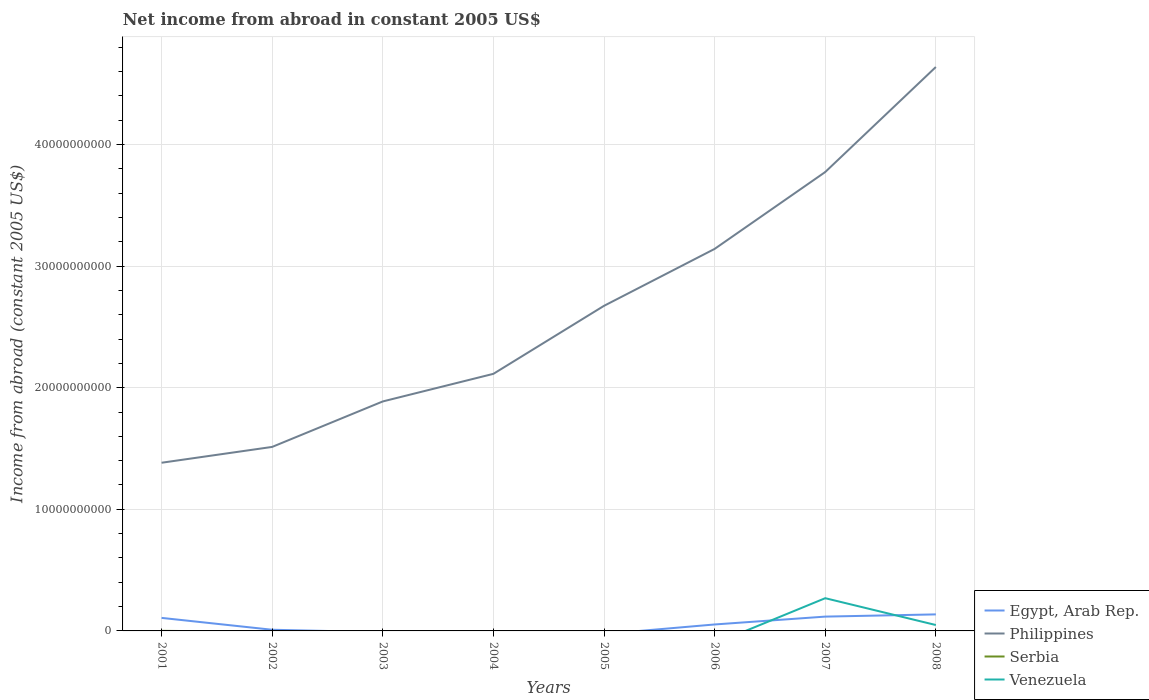How many different coloured lines are there?
Make the answer very short. 4. What is the total net income from abroad in Philippines in the graph?
Give a very brief answer. -1.30e+09. What is the difference between the highest and the second highest net income from abroad in Serbia?
Ensure brevity in your answer.  6.03e+06. How many lines are there?
Your answer should be very brief. 4. How many years are there in the graph?
Keep it short and to the point. 8. Are the values on the major ticks of Y-axis written in scientific E-notation?
Offer a very short reply. No. Does the graph contain any zero values?
Provide a succinct answer. Yes. Does the graph contain grids?
Keep it short and to the point. Yes. How are the legend labels stacked?
Offer a terse response. Vertical. What is the title of the graph?
Provide a succinct answer. Net income from abroad in constant 2005 US$. What is the label or title of the Y-axis?
Ensure brevity in your answer.  Income from abroad (constant 2005 US$). What is the Income from abroad (constant 2005 US$) of Egypt, Arab Rep. in 2001?
Give a very brief answer. 1.07e+09. What is the Income from abroad (constant 2005 US$) of Philippines in 2001?
Provide a short and direct response. 1.38e+1. What is the Income from abroad (constant 2005 US$) in Serbia in 2001?
Your answer should be very brief. 6.03e+06. What is the Income from abroad (constant 2005 US$) in Egypt, Arab Rep. in 2002?
Your answer should be very brief. 9.59e+07. What is the Income from abroad (constant 2005 US$) in Philippines in 2002?
Make the answer very short. 1.51e+1. What is the Income from abroad (constant 2005 US$) in Serbia in 2002?
Make the answer very short. 0. What is the Income from abroad (constant 2005 US$) of Philippines in 2003?
Offer a very short reply. 1.89e+1. What is the Income from abroad (constant 2005 US$) of Serbia in 2003?
Your answer should be compact. 0. What is the Income from abroad (constant 2005 US$) in Venezuela in 2003?
Provide a succinct answer. 0. What is the Income from abroad (constant 2005 US$) of Philippines in 2004?
Ensure brevity in your answer.  2.11e+1. What is the Income from abroad (constant 2005 US$) in Egypt, Arab Rep. in 2005?
Make the answer very short. 0. What is the Income from abroad (constant 2005 US$) in Philippines in 2005?
Offer a terse response. 2.67e+1. What is the Income from abroad (constant 2005 US$) in Serbia in 2005?
Ensure brevity in your answer.  0. What is the Income from abroad (constant 2005 US$) in Egypt, Arab Rep. in 2006?
Keep it short and to the point. 5.31e+08. What is the Income from abroad (constant 2005 US$) in Philippines in 2006?
Keep it short and to the point. 3.14e+1. What is the Income from abroad (constant 2005 US$) in Serbia in 2006?
Provide a short and direct response. 0. What is the Income from abroad (constant 2005 US$) of Venezuela in 2006?
Your response must be concise. 0. What is the Income from abroad (constant 2005 US$) in Egypt, Arab Rep. in 2007?
Ensure brevity in your answer.  1.18e+09. What is the Income from abroad (constant 2005 US$) of Philippines in 2007?
Make the answer very short. 3.77e+1. What is the Income from abroad (constant 2005 US$) of Serbia in 2007?
Offer a terse response. 0. What is the Income from abroad (constant 2005 US$) in Venezuela in 2007?
Provide a short and direct response. 2.69e+09. What is the Income from abroad (constant 2005 US$) of Egypt, Arab Rep. in 2008?
Provide a succinct answer. 1.36e+09. What is the Income from abroad (constant 2005 US$) in Philippines in 2008?
Make the answer very short. 4.64e+1. What is the Income from abroad (constant 2005 US$) in Venezuela in 2008?
Keep it short and to the point. 4.85e+08. Across all years, what is the maximum Income from abroad (constant 2005 US$) in Egypt, Arab Rep.?
Provide a short and direct response. 1.36e+09. Across all years, what is the maximum Income from abroad (constant 2005 US$) in Philippines?
Offer a terse response. 4.64e+1. Across all years, what is the maximum Income from abroad (constant 2005 US$) in Serbia?
Offer a terse response. 6.03e+06. Across all years, what is the maximum Income from abroad (constant 2005 US$) in Venezuela?
Your answer should be compact. 2.69e+09. Across all years, what is the minimum Income from abroad (constant 2005 US$) of Philippines?
Offer a very short reply. 1.38e+1. What is the total Income from abroad (constant 2005 US$) of Egypt, Arab Rep. in the graph?
Give a very brief answer. 4.24e+09. What is the total Income from abroad (constant 2005 US$) in Philippines in the graph?
Your answer should be very brief. 2.11e+11. What is the total Income from abroad (constant 2005 US$) in Serbia in the graph?
Provide a succinct answer. 6.03e+06. What is the total Income from abroad (constant 2005 US$) of Venezuela in the graph?
Keep it short and to the point. 3.18e+09. What is the difference between the Income from abroad (constant 2005 US$) in Egypt, Arab Rep. in 2001 and that in 2002?
Provide a succinct answer. 9.76e+08. What is the difference between the Income from abroad (constant 2005 US$) in Philippines in 2001 and that in 2002?
Make the answer very short. -1.30e+09. What is the difference between the Income from abroad (constant 2005 US$) of Philippines in 2001 and that in 2003?
Offer a very short reply. -5.04e+09. What is the difference between the Income from abroad (constant 2005 US$) in Philippines in 2001 and that in 2004?
Keep it short and to the point. -7.31e+09. What is the difference between the Income from abroad (constant 2005 US$) of Philippines in 2001 and that in 2005?
Make the answer very short. -1.29e+1. What is the difference between the Income from abroad (constant 2005 US$) of Egypt, Arab Rep. in 2001 and that in 2006?
Your answer should be very brief. 5.41e+08. What is the difference between the Income from abroad (constant 2005 US$) of Philippines in 2001 and that in 2006?
Keep it short and to the point. -1.76e+1. What is the difference between the Income from abroad (constant 2005 US$) in Egypt, Arab Rep. in 2001 and that in 2007?
Provide a short and direct response. -1.06e+08. What is the difference between the Income from abroad (constant 2005 US$) in Philippines in 2001 and that in 2007?
Offer a very short reply. -2.39e+1. What is the difference between the Income from abroad (constant 2005 US$) of Egypt, Arab Rep. in 2001 and that in 2008?
Keep it short and to the point. -2.88e+08. What is the difference between the Income from abroad (constant 2005 US$) of Philippines in 2001 and that in 2008?
Your answer should be very brief. -3.25e+1. What is the difference between the Income from abroad (constant 2005 US$) in Philippines in 2002 and that in 2003?
Give a very brief answer. -3.74e+09. What is the difference between the Income from abroad (constant 2005 US$) in Philippines in 2002 and that in 2004?
Provide a short and direct response. -6.01e+09. What is the difference between the Income from abroad (constant 2005 US$) in Philippines in 2002 and that in 2005?
Your response must be concise. -1.16e+1. What is the difference between the Income from abroad (constant 2005 US$) in Egypt, Arab Rep. in 2002 and that in 2006?
Provide a succinct answer. -4.35e+08. What is the difference between the Income from abroad (constant 2005 US$) of Philippines in 2002 and that in 2006?
Give a very brief answer. -1.63e+1. What is the difference between the Income from abroad (constant 2005 US$) of Egypt, Arab Rep. in 2002 and that in 2007?
Give a very brief answer. -1.08e+09. What is the difference between the Income from abroad (constant 2005 US$) in Philippines in 2002 and that in 2007?
Ensure brevity in your answer.  -2.26e+1. What is the difference between the Income from abroad (constant 2005 US$) in Egypt, Arab Rep. in 2002 and that in 2008?
Offer a terse response. -1.26e+09. What is the difference between the Income from abroad (constant 2005 US$) of Philippines in 2002 and that in 2008?
Offer a very short reply. -3.12e+1. What is the difference between the Income from abroad (constant 2005 US$) in Philippines in 2003 and that in 2004?
Offer a terse response. -2.27e+09. What is the difference between the Income from abroad (constant 2005 US$) in Philippines in 2003 and that in 2005?
Provide a succinct answer. -7.86e+09. What is the difference between the Income from abroad (constant 2005 US$) in Philippines in 2003 and that in 2006?
Provide a succinct answer. -1.25e+1. What is the difference between the Income from abroad (constant 2005 US$) in Philippines in 2003 and that in 2007?
Your answer should be very brief. -1.89e+1. What is the difference between the Income from abroad (constant 2005 US$) in Philippines in 2003 and that in 2008?
Provide a succinct answer. -2.75e+1. What is the difference between the Income from abroad (constant 2005 US$) in Philippines in 2004 and that in 2005?
Your answer should be compact. -5.59e+09. What is the difference between the Income from abroad (constant 2005 US$) in Philippines in 2004 and that in 2006?
Offer a very short reply. -1.03e+1. What is the difference between the Income from abroad (constant 2005 US$) in Philippines in 2004 and that in 2007?
Offer a terse response. -1.66e+1. What is the difference between the Income from abroad (constant 2005 US$) of Philippines in 2004 and that in 2008?
Your answer should be very brief. -2.52e+1. What is the difference between the Income from abroad (constant 2005 US$) in Philippines in 2005 and that in 2006?
Keep it short and to the point. -4.68e+09. What is the difference between the Income from abroad (constant 2005 US$) in Philippines in 2005 and that in 2007?
Offer a very short reply. -1.10e+1. What is the difference between the Income from abroad (constant 2005 US$) in Philippines in 2005 and that in 2008?
Provide a succinct answer. -1.96e+1. What is the difference between the Income from abroad (constant 2005 US$) of Egypt, Arab Rep. in 2006 and that in 2007?
Keep it short and to the point. -6.46e+08. What is the difference between the Income from abroad (constant 2005 US$) of Philippines in 2006 and that in 2007?
Provide a succinct answer. -6.32e+09. What is the difference between the Income from abroad (constant 2005 US$) of Egypt, Arab Rep. in 2006 and that in 2008?
Provide a succinct answer. -8.29e+08. What is the difference between the Income from abroad (constant 2005 US$) in Philippines in 2006 and that in 2008?
Provide a succinct answer. -1.50e+1. What is the difference between the Income from abroad (constant 2005 US$) in Egypt, Arab Rep. in 2007 and that in 2008?
Offer a terse response. -1.82e+08. What is the difference between the Income from abroad (constant 2005 US$) in Philippines in 2007 and that in 2008?
Provide a short and direct response. -8.64e+09. What is the difference between the Income from abroad (constant 2005 US$) in Venezuela in 2007 and that in 2008?
Ensure brevity in your answer.  2.21e+09. What is the difference between the Income from abroad (constant 2005 US$) of Egypt, Arab Rep. in 2001 and the Income from abroad (constant 2005 US$) of Philippines in 2002?
Your response must be concise. -1.41e+1. What is the difference between the Income from abroad (constant 2005 US$) of Egypt, Arab Rep. in 2001 and the Income from abroad (constant 2005 US$) of Philippines in 2003?
Keep it short and to the point. -1.78e+1. What is the difference between the Income from abroad (constant 2005 US$) of Egypt, Arab Rep. in 2001 and the Income from abroad (constant 2005 US$) of Philippines in 2004?
Offer a very short reply. -2.01e+1. What is the difference between the Income from abroad (constant 2005 US$) of Egypt, Arab Rep. in 2001 and the Income from abroad (constant 2005 US$) of Philippines in 2005?
Your answer should be very brief. -2.57e+1. What is the difference between the Income from abroad (constant 2005 US$) of Egypt, Arab Rep. in 2001 and the Income from abroad (constant 2005 US$) of Philippines in 2006?
Offer a very short reply. -3.03e+1. What is the difference between the Income from abroad (constant 2005 US$) of Egypt, Arab Rep. in 2001 and the Income from abroad (constant 2005 US$) of Philippines in 2007?
Your answer should be very brief. -3.67e+1. What is the difference between the Income from abroad (constant 2005 US$) in Egypt, Arab Rep. in 2001 and the Income from abroad (constant 2005 US$) in Venezuela in 2007?
Your response must be concise. -1.62e+09. What is the difference between the Income from abroad (constant 2005 US$) of Philippines in 2001 and the Income from abroad (constant 2005 US$) of Venezuela in 2007?
Make the answer very short. 1.11e+1. What is the difference between the Income from abroad (constant 2005 US$) in Serbia in 2001 and the Income from abroad (constant 2005 US$) in Venezuela in 2007?
Ensure brevity in your answer.  -2.69e+09. What is the difference between the Income from abroad (constant 2005 US$) of Egypt, Arab Rep. in 2001 and the Income from abroad (constant 2005 US$) of Philippines in 2008?
Provide a succinct answer. -4.53e+1. What is the difference between the Income from abroad (constant 2005 US$) in Egypt, Arab Rep. in 2001 and the Income from abroad (constant 2005 US$) in Venezuela in 2008?
Offer a very short reply. 5.87e+08. What is the difference between the Income from abroad (constant 2005 US$) of Philippines in 2001 and the Income from abroad (constant 2005 US$) of Venezuela in 2008?
Provide a short and direct response. 1.33e+1. What is the difference between the Income from abroad (constant 2005 US$) of Serbia in 2001 and the Income from abroad (constant 2005 US$) of Venezuela in 2008?
Your response must be concise. -4.79e+08. What is the difference between the Income from abroad (constant 2005 US$) in Egypt, Arab Rep. in 2002 and the Income from abroad (constant 2005 US$) in Philippines in 2003?
Provide a short and direct response. -1.88e+1. What is the difference between the Income from abroad (constant 2005 US$) in Egypt, Arab Rep. in 2002 and the Income from abroad (constant 2005 US$) in Philippines in 2004?
Provide a short and direct response. -2.10e+1. What is the difference between the Income from abroad (constant 2005 US$) of Egypt, Arab Rep. in 2002 and the Income from abroad (constant 2005 US$) of Philippines in 2005?
Give a very brief answer. -2.66e+1. What is the difference between the Income from abroad (constant 2005 US$) of Egypt, Arab Rep. in 2002 and the Income from abroad (constant 2005 US$) of Philippines in 2006?
Ensure brevity in your answer.  -3.13e+1. What is the difference between the Income from abroad (constant 2005 US$) in Egypt, Arab Rep. in 2002 and the Income from abroad (constant 2005 US$) in Philippines in 2007?
Your answer should be compact. -3.76e+1. What is the difference between the Income from abroad (constant 2005 US$) in Egypt, Arab Rep. in 2002 and the Income from abroad (constant 2005 US$) in Venezuela in 2007?
Offer a very short reply. -2.60e+09. What is the difference between the Income from abroad (constant 2005 US$) in Philippines in 2002 and the Income from abroad (constant 2005 US$) in Venezuela in 2007?
Offer a very short reply. 1.24e+1. What is the difference between the Income from abroad (constant 2005 US$) in Egypt, Arab Rep. in 2002 and the Income from abroad (constant 2005 US$) in Philippines in 2008?
Offer a terse response. -4.63e+1. What is the difference between the Income from abroad (constant 2005 US$) of Egypt, Arab Rep. in 2002 and the Income from abroad (constant 2005 US$) of Venezuela in 2008?
Make the answer very short. -3.89e+08. What is the difference between the Income from abroad (constant 2005 US$) of Philippines in 2002 and the Income from abroad (constant 2005 US$) of Venezuela in 2008?
Your answer should be compact. 1.46e+1. What is the difference between the Income from abroad (constant 2005 US$) of Philippines in 2003 and the Income from abroad (constant 2005 US$) of Venezuela in 2007?
Offer a very short reply. 1.62e+1. What is the difference between the Income from abroad (constant 2005 US$) of Philippines in 2003 and the Income from abroad (constant 2005 US$) of Venezuela in 2008?
Offer a terse response. 1.84e+1. What is the difference between the Income from abroad (constant 2005 US$) of Philippines in 2004 and the Income from abroad (constant 2005 US$) of Venezuela in 2007?
Make the answer very short. 1.84e+1. What is the difference between the Income from abroad (constant 2005 US$) of Philippines in 2004 and the Income from abroad (constant 2005 US$) of Venezuela in 2008?
Offer a very short reply. 2.07e+1. What is the difference between the Income from abroad (constant 2005 US$) of Philippines in 2005 and the Income from abroad (constant 2005 US$) of Venezuela in 2007?
Your answer should be compact. 2.40e+1. What is the difference between the Income from abroad (constant 2005 US$) in Philippines in 2005 and the Income from abroad (constant 2005 US$) in Venezuela in 2008?
Give a very brief answer. 2.62e+1. What is the difference between the Income from abroad (constant 2005 US$) in Egypt, Arab Rep. in 2006 and the Income from abroad (constant 2005 US$) in Philippines in 2007?
Provide a succinct answer. -3.72e+1. What is the difference between the Income from abroad (constant 2005 US$) of Egypt, Arab Rep. in 2006 and the Income from abroad (constant 2005 US$) of Venezuela in 2007?
Make the answer very short. -2.16e+09. What is the difference between the Income from abroad (constant 2005 US$) of Philippines in 2006 and the Income from abroad (constant 2005 US$) of Venezuela in 2007?
Provide a short and direct response. 2.87e+1. What is the difference between the Income from abroad (constant 2005 US$) of Egypt, Arab Rep. in 2006 and the Income from abroad (constant 2005 US$) of Philippines in 2008?
Your answer should be compact. -4.58e+1. What is the difference between the Income from abroad (constant 2005 US$) in Egypt, Arab Rep. in 2006 and the Income from abroad (constant 2005 US$) in Venezuela in 2008?
Ensure brevity in your answer.  4.60e+07. What is the difference between the Income from abroad (constant 2005 US$) of Philippines in 2006 and the Income from abroad (constant 2005 US$) of Venezuela in 2008?
Give a very brief answer. 3.09e+1. What is the difference between the Income from abroad (constant 2005 US$) in Egypt, Arab Rep. in 2007 and the Income from abroad (constant 2005 US$) in Philippines in 2008?
Ensure brevity in your answer.  -4.52e+1. What is the difference between the Income from abroad (constant 2005 US$) in Egypt, Arab Rep. in 2007 and the Income from abroad (constant 2005 US$) in Venezuela in 2008?
Make the answer very short. 6.92e+08. What is the difference between the Income from abroad (constant 2005 US$) of Philippines in 2007 and the Income from abroad (constant 2005 US$) of Venezuela in 2008?
Your response must be concise. 3.73e+1. What is the average Income from abroad (constant 2005 US$) in Egypt, Arab Rep. per year?
Keep it short and to the point. 5.29e+08. What is the average Income from abroad (constant 2005 US$) in Philippines per year?
Provide a short and direct response. 2.64e+1. What is the average Income from abroad (constant 2005 US$) in Serbia per year?
Give a very brief answer. 7.54e+05. What is the average Income from abroad (constant 2005 US$) of Venezuela per year?
Your response must be concise. 3.97e+08. In the year 2001, what is the difference between the Income from abroad (constant 2005 US$) in Egypt, Arab Rep. and Income from abroad (constant 2005 US$) in Philippines?
Provide a short and direct response. -1.28e+1. In the year 2001, what is the difference between the Income from abroad (constant 2005 US$) of Egypt, Arab Rep. and Income from abroad (constant 2005 US$) of Serbia?
Offer a very short reply. 1.07e+09. In the year 2001, what is the difference between the Income from abroad (constant 2005 US$) of Philippines and Income from abroad (constant 2005 US$) of Serbia?
Your response must be concise. 1.38e+1. In the year 2002, what is the difference between the Income from abroad (constant 2005 US$) of Egypt, Arab Rep. and Income from abroad (constant 2005 US$) of Philippines?
Give a very brief answer. -1.50e+1. In the year 2006, what is the difference between the Income from abroad (constant 2005 US$) of Egypt, Arab Rep. and Income from abroad (constant 2005 US$) of Philippines?
Your response must be concise. -3.09e+1. In the year 2007, what is the difference between the Income from abroad (constant 2005 US$) of Egypt, Arab Rep. and Income from abroad (constant 2005 US$) of Philippines?
Provide a short and direct response. -3.66e+1. In the year 2007, what is the difference between the Income from abroad (constant 2005 US$) of Egypt, Arab Rep. and Income from abroad (constant 2005 US$) of Venezuela?
Offer a terse response. -1.51e+09. In the year 2007, what is the difference between the Income from abroad (constant 2005 US$) in Philippines and Income from abroad (constant 2005 US$) in Venezuela?
Provide a succinct answer. 3.50e+1. In the year 2008, what is the difference between the Income from abroad (constant 2005 US$) in Egypt, Arab Rep. and Income from abroad (constant 2005 US$) in Philippines?
Offer a very short reply. -4.50e+1. In the year 2008, what is the difference between the Income from abroad (constant 2005 US$) of Egypt, Arab Rep. and Income from abroad (constant 2005 US$) of Venezuela?
Provide a succinct answer. 8.75e+08. In the year 2008, what is the difference between the Income from abroad (constant 2005 US$) of Philippines and Income from abroad (constant 2005 US$) of Venezuela?
Provide a short and direct response. 4.59e+1. What is the ratio of the Income from abroad (constant 2005 US$) in Egypt, Arab Rep. in 2001 to that in 2002?
Ensure brevity in your answer.  11.17. What is the ratio of the Income from abroad (constant 2005 US$) of Philippines in 2001 to that in 2002?
Your answer should be very brief. 0.91. What is the ratio of the Income from abroad (constant 2005 US$) of Philippines in 2001 to that in 2003?
Give a very brief answer. 0.73. What is the ratio of the Income from abroad (constant 2005 US$) of Philippines in 2001 to that in 2004?
Provide a short and direct response. 0.65. What is the ratio of the Income from abroad (constant 2005 US$) of Philippines in 2001 to that in 2005?
Your response must be concise. 0.52. What is the ratio of the Income from abroad (constant 2005 US$) in Egypt, Arab Rep. in 2001 to that in 2006?
Make the answer very short. 2.02. What is the ratio of the Income from abroad (constant 2005 US$) of Philippines in 2001 to that in 2006?
Provide a succinct answer. 0.44. What is the ratio of the Income from abroad (constant 2005 US$) of Egypt, Arab Rep. in 2001 to that in 2007?
Give a very brief answer. 0.91. What is the ratio of the Income from abroad (constant 2005 US$) in Philippines in 2001 to that in 2007?
Your response must be concise. 0.37. What is the ratio of the Income from abroad (constant 2005 US$) in Egypt, Arab Rep. in 2001 to that in 2008?
Give a very brief answer. 0.79. What is the ratio of the Income from abroad (constant 2005 US$) in Philippines in 2001 to that in 2008?
Your answer should be very brief. 0.3. What is the ratio of the Income from abroad (constant 2005 US$) in Philippines in 2002 to that in 2003?
Offer a very short reply. 0.8. What is the ratio of the Income from abroad (constant 2005 US$) of Philippines in 2002 to that in 2004?
Make the answer very short. 0.72. What is the ratio of the Income from abroad (constant 2005 US$) of Philippines in 2002 to that in 2005?
Offer a very short reply. 0.57. What is the ratio of the Income from abroad (constant 2005 US$) of Egypt, Arab Rep. in 2002 to that in 2006?
Keep it short and to the point. 0.18. What is the ratio of the Income from abroad (constant 2005 US$) of Philippines in 2002 to that in 2006?
Provide a succinct answer. 0.48. What is the ratio of the Income from abroad (constant 2005 US$) in Egypt, Arab Rep. in 2002 to that in 2007?
Offer a very short reply. 0.08. What is the ratio of the Income from abroad (constant 2005 US$) in Philippines in 2002 to that in 2007?
Offer a very short reply. 0.4. What is the ratio of the Income from abroad (constant 2005 US$) of Egypt, Arab Rep. in 2002 to that in 2008?
Keep it short and to the point. 0.07. What is the ratio of the Income from abroad (constant 2005 US$) of Philippines in 2002 to that in 2008?
Offer a terse response. 0.33. What is the ratio of the Income from abroad (constant 2005 US$) of Philippines in 2003 to that in 2004?
Make the answer very short. 0.89. What is the ratio of the Income from abroad (constant 2005 US$) of Philippines in 2003 to that in 2005?
Offer a terse response. 0.71. What is the ratio of the Income from abroad (constant 2005 US$) in Philippines in 2003 to that in 2006?
Your answer should be very brief. 0.6. What is the ratio of the Income from abroad (constant 2005 US$) in Philippines in 2003 to that in 2007?
Offer a very short reply. 0.5. What is the ratio of the Income from abroad (constant 2005 US$) of Philippines in 2003 to that in 2008?
Your answer should be very brief. 0.41. What is the ratio of the Income from abroad (constant 2005 US$) of Philippines in 2004 to that in 2005?
Offer a terse response. 0.79. What is the ratio of the Income from abroad (constant 2005 US$) of Philippines in 2004 to that in 2006?
Offer a terse response. 0.67. What is the ratio of the Income from abroad (constant 2005 US$) in Philippines in 2004 to that in 2007?
Provide a short and direct response. 0.56. What is the ratio of the Income from abroad (constant 2005 US$) in Philippines in 2004 to that in 2008?
Make the answer very short. 0.46. What is the ratio of the Income from abroad (constant 2005 US$) in Philippines in 2005 to that in 2006?
Keep it short and to the point. 0.85. What is the ratio of the Income from abroad (constant 2005 US$) of Philippines in 2005 to that in 2007?
Offer a terse response. 0.71. What is the ratio of the Income from abroad (constant 2005 US$) of Philippines in 2005 to that in 2008?
Give a very brief answer. 0.58. What is the ratio of the Income from abroad (constant 2005 US$) of Egypt, Arab Rep. in 2006 to that in 2007?
Your response must be concise. 0.45. What is the ratio of the Income from abroad (constant 2005 US$) of Philippines in 2006 to that in 2007?
Provide a short and direct response. 0.83. What is the ratio of the Income from abroad (constant 2005 US$) in Egypt, Arab Rep. in 2006 to that in 2008?
Provide a short and direct response. 0.39. What is the ratio of the Income from abroad (constant 2005 US$) of Philippines in 2006 to that in 2008?
Ensure brevity in your answer.  0.68. What is the ratio of the Income from abroad (constant 2005 US$) of Egypt, Arab Rep. in 2007 to that in 2008?
Your answer should be very brief. 0.87. What is the ratio of the Income from abroad (constant 2005 US$) in Philippines in 2007 to that in 2008?
Provide a short and direct response. 0.81. What is the ratio of the Income from abroad (constant 2005 US$) in Venezuela in 2007 to that in 2008?
Your answer should be very brief. 5.55. What is the difference between the highest and the second highest Income from abroad (constant 2005 US$) in Egypt, Arab Rep.?
Provide a short and direct response. 1.82e+08. What is the difference between the highest and the second highest Income from abroad (constant 2005 US$) in Philippines?
Offer a very short reply. 8.64e+09. What is the difference between the highest and the lowest Income from abroad (constant 2005 US$) in Egypt, Arab Rep.?
Make the answer very short. 1.36e+09. What is the difference between the highest and the lowest Income from abroad (constant 2005 US$) of Philippines?
Ensure brevity in your answer.  3.25e+1. What is the difference between the highest and the lowest Income from abroad (constant 2005 US$) in Serbia?
Your response must be concise. 6.03e+06. What is the difference between the highest and the lowest Income from abroad (constant 2005 US$) in Venezuela?
Provide a short and direct response. 2.69e+09. 